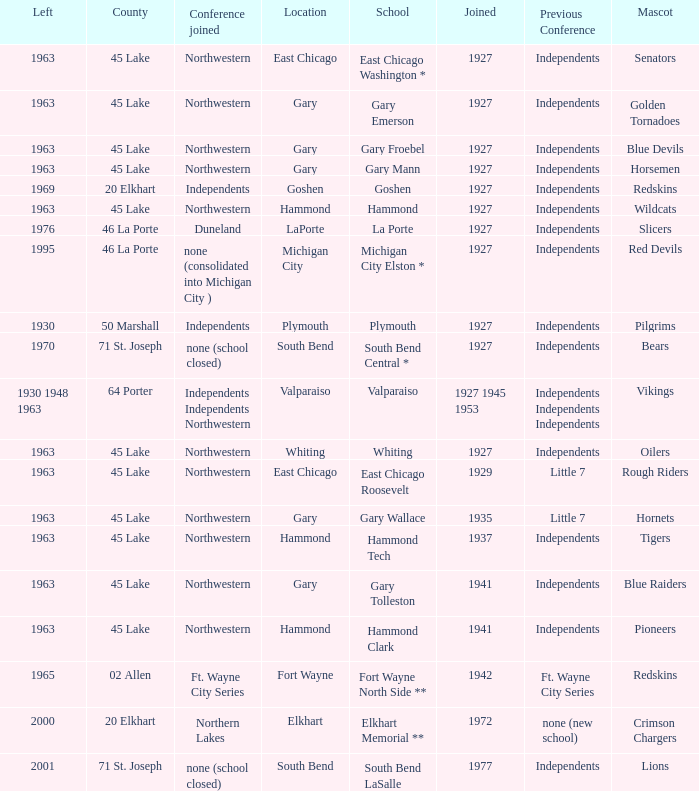When doeas Mascot of blue devils in Gary Froebel School? 1927.0. 